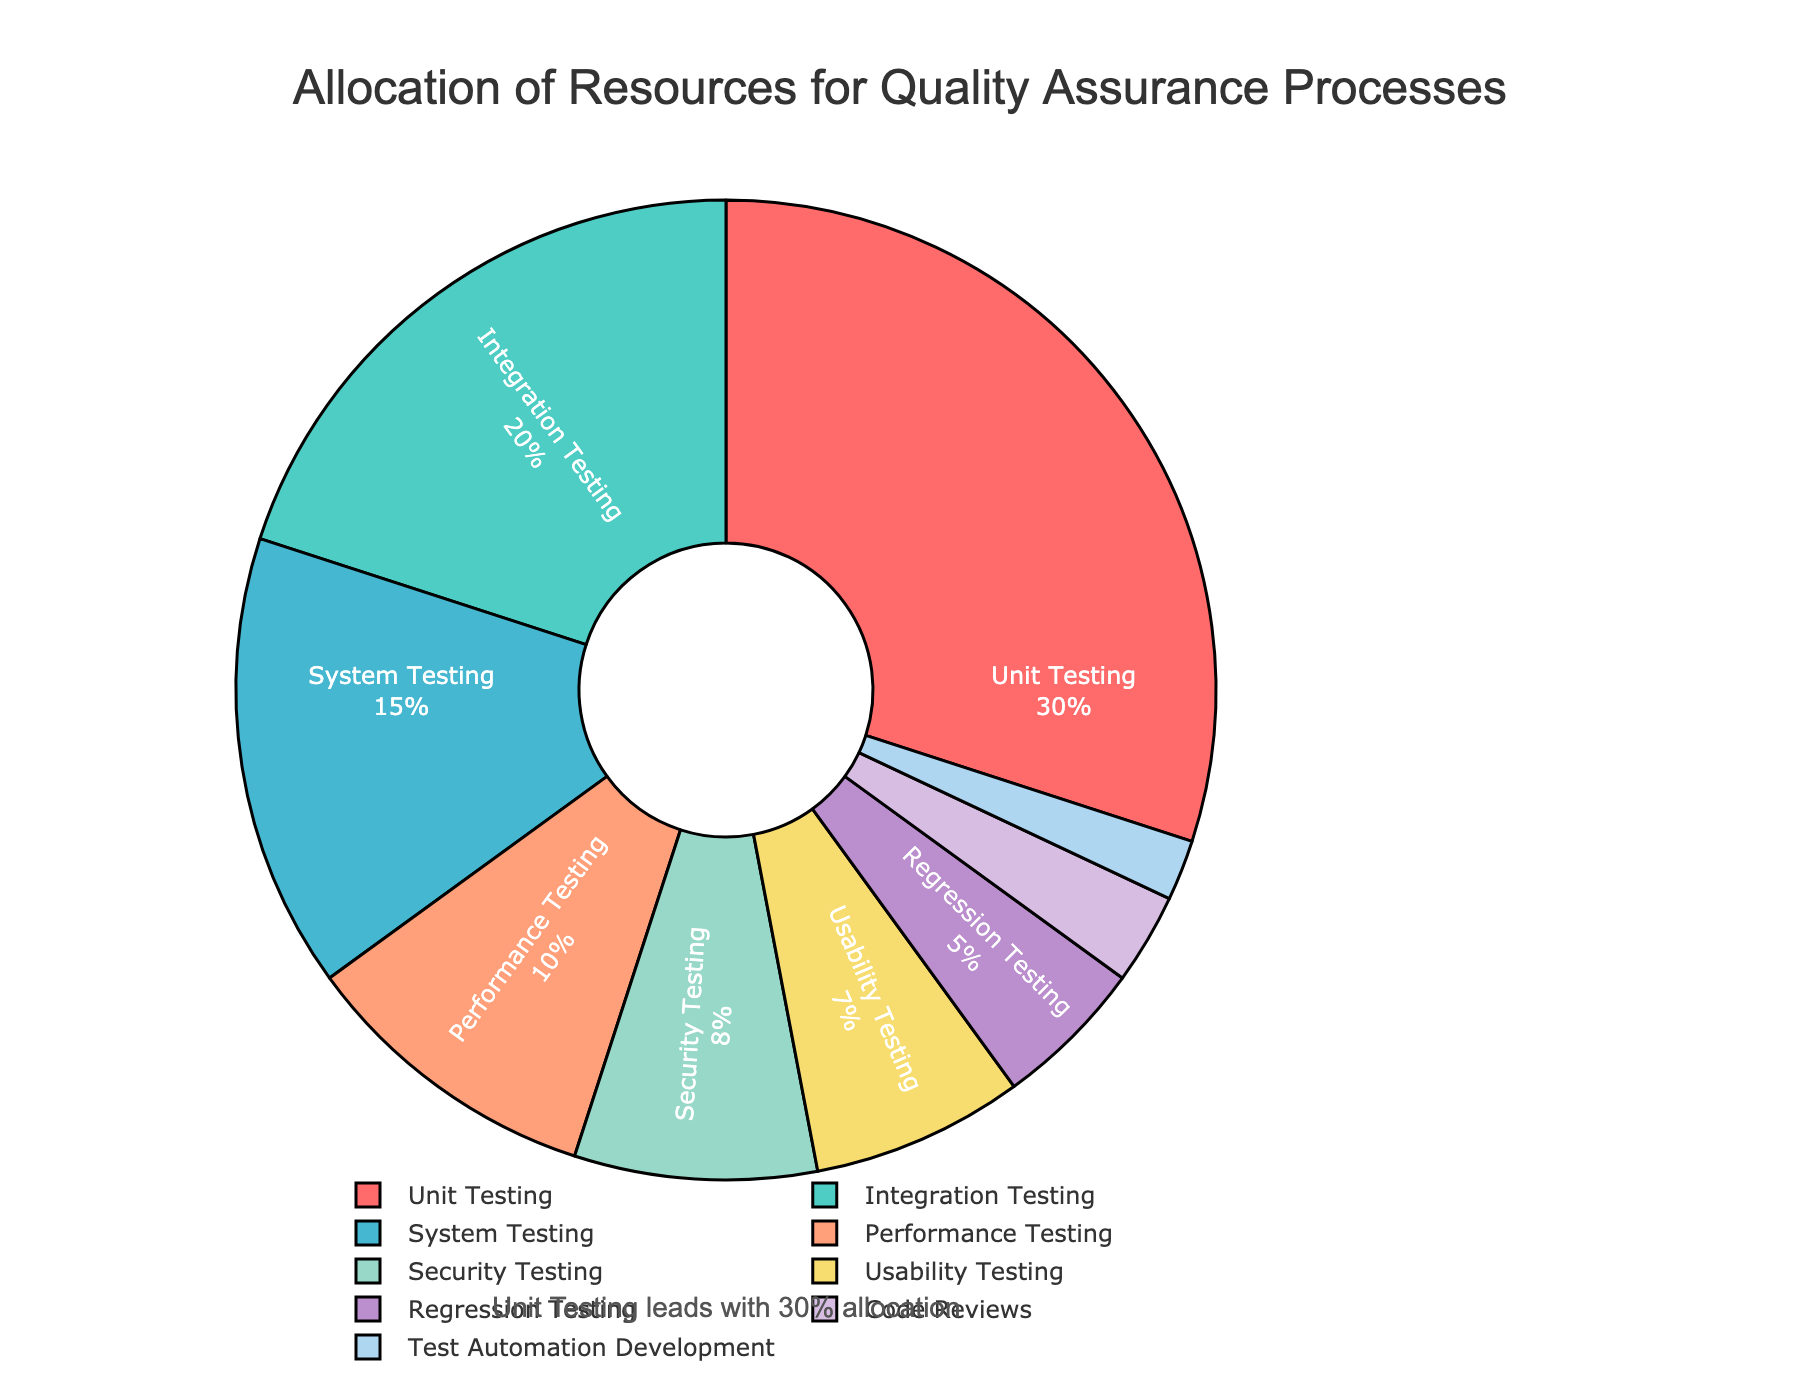Which process has the highest allocation percentage? By looking at the pie chart, the process with the largest segment should be identified. According to the figure, "Unit Testing" occupies the largest portion.
Answer: Unit Testing What is the total percentage allocated to Performance Testing, Security Testing, and Usability Testing? Sum the percentages of the three processes: Performance Testing (10%), Security Testing (8%), and Usability Testing (7%). Therefore, the total is 10% + 8% + 7% = 25%.
Answer: 25% How much more resource is allocated to Integration Testing compared to Regression Testing? Refer to the segments for Integration Testing and Regression Testing and find the difference: Integration Testing (20%) and Regression Testing (5%). So, the difference is 20% - 5% = 15%.
Answer: 15% Which processes cumulatively take up a quarter of the total resources? Identify the processes whose combined percentages approximate 25%. Here, Performance Testing (10%), Security Testing (8%), Usability Testing (7%), and Regression Testing (5%) together sum to 10% + 8% + 7% + 5% = 30%, which is close to a quarter (though slightly more).
Answer: Performance Testing, Security Testing, Usability Testing, Regression Testing Which process has the smallest resource allocation, and what percentage is it? By examining the pie chart for the smallest segment, the process with the least allocation is "Test Automation Development" with 2%.
Answer: Test Automation Development, 2% How does the resource allocation for System Testing compare to that for Code Reviews? Compare the segments representing System Testing and Code Reviews: System Testing is allocated 15%, whereas Code Reviews are allocated 3%. System Testing allocation is therefore significantly higher.
Answer: System Testing has 12% more What percentage is dedicated to both Unit Testing and Integration Testing combined? Sum the percentages allocated to both processes: Unit Testing (30%) and Integration Testing (20%). Together, they account for 30% + 20% = 50%.
Answer: 50% What color represents Performance Testing? Identify the color assigned to the Performance Testing segment in the pie chart. According to the figure, Performance Testing is represented by orange (#FFA07A).
Answer: Orange How does the allocation for Usability Testing compare to the allocation for Regression Testing? Compare the percentages: Usability Testing is allocated 7%, and Regression Testing is allocated 5%. Usability Testing has a 2% higher allocation.
Answer: Usability Testing has 2% more 